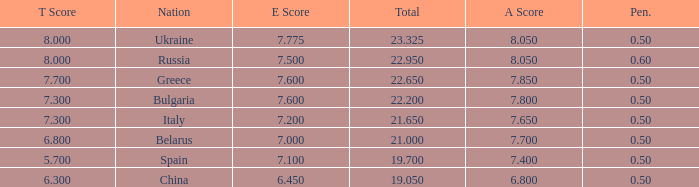What E score has the T score of 8 and a number smaller than 22.95? None. 